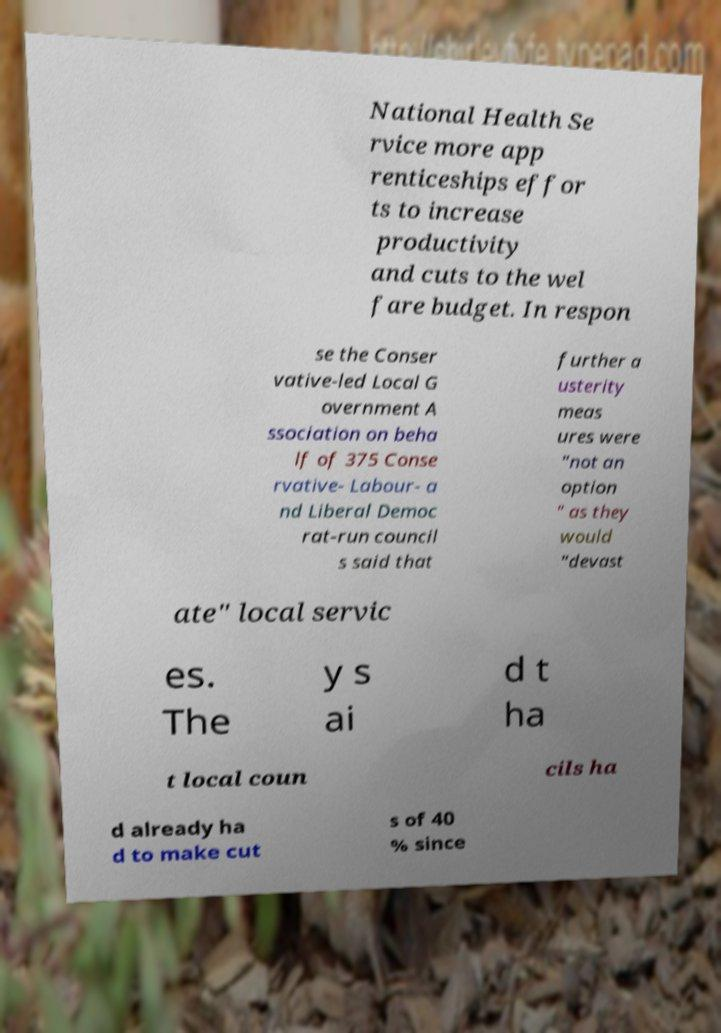Please identify and transcribe the text found in this image. National Health Se rvice more app renticeships effor ts to increase productivity and cuts to the wel fare budget. In respon se the Conser vative-led Local G overnment A ssociation on beha lf of 375 Conse rvative- Labour- a nd Liberal Democ rat-run council s said that further a usterity meas ures were "not an option " as they would "devast ate" local servic es. The y s ai d t ha t local coun cils ha d already ha d to make cut s of 40 % since 